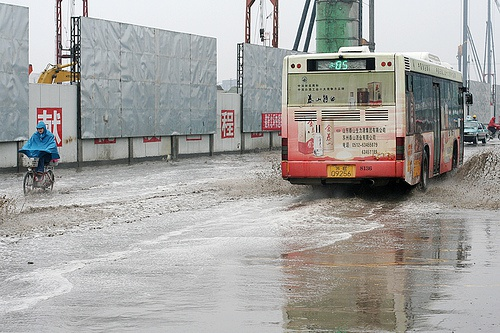Describe the objects in this image and their specific colors. I can see bus in lavender, gray, darkgray, black, and lightgray tones, people in lavender, black, teal, and navy tones, bicycle in lavender, gray, darkgray, black, and navy tones, car in lavender, darkgray, black, and gray tones, and people in lavender, black, brown, and maroon tones in this image. 